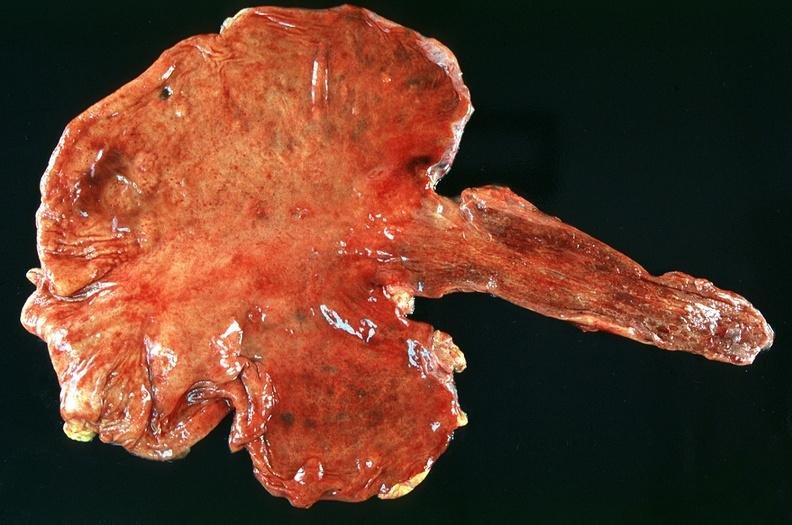what is present?
Answer the question using a single word or phrase. Gastrointestinal 